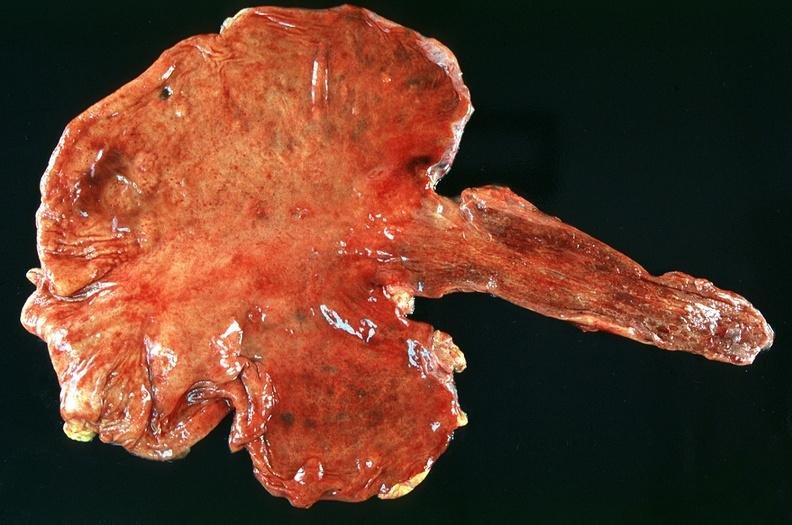what is present?
Answer the question using a single word or phrase. Gastrointestinal 